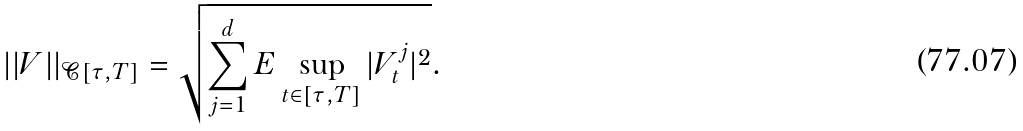Convert formula to latex. <formula><loc_0><loc_0><loc_500><loc_500>| | V | | _ { \mathcal { C } [ \tau , T ] } = \sqrt { \sum _ { j = 1 } ^ { d } E \sup _ { t \in [ \tau , T ] } | V _ { t } ^ { j } | ^ { 2 } } \text {.}</formula> 